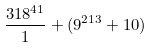Convert formula to latex. <formula><loc_0><loc_0><loc_500><loc_500>\frac { 3 1 8 ^ { 4 1 } } { 1 } + ( 9 ^ { 2 1 3 } + 1 0 )</formula> 